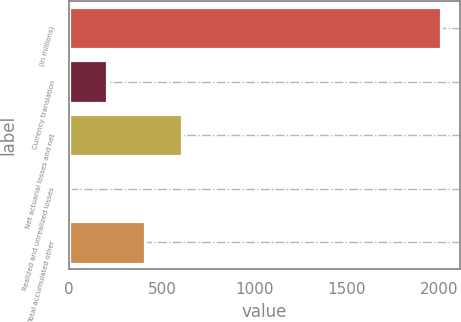Convert chart to OTSL. <chart><loc_0><loc_0><loc_500><loc_500><bar_chart><fcel>(in millions)<fcel>Currency translation<fcel>Net actuarial losses and net<fcel>Realized and unrealized losses<fcel>Total accumulated other<nl><fcel>2010<fcel>206.04<fcel>606.92<fcel>5.6<fcel>406.48<nl></chart> 